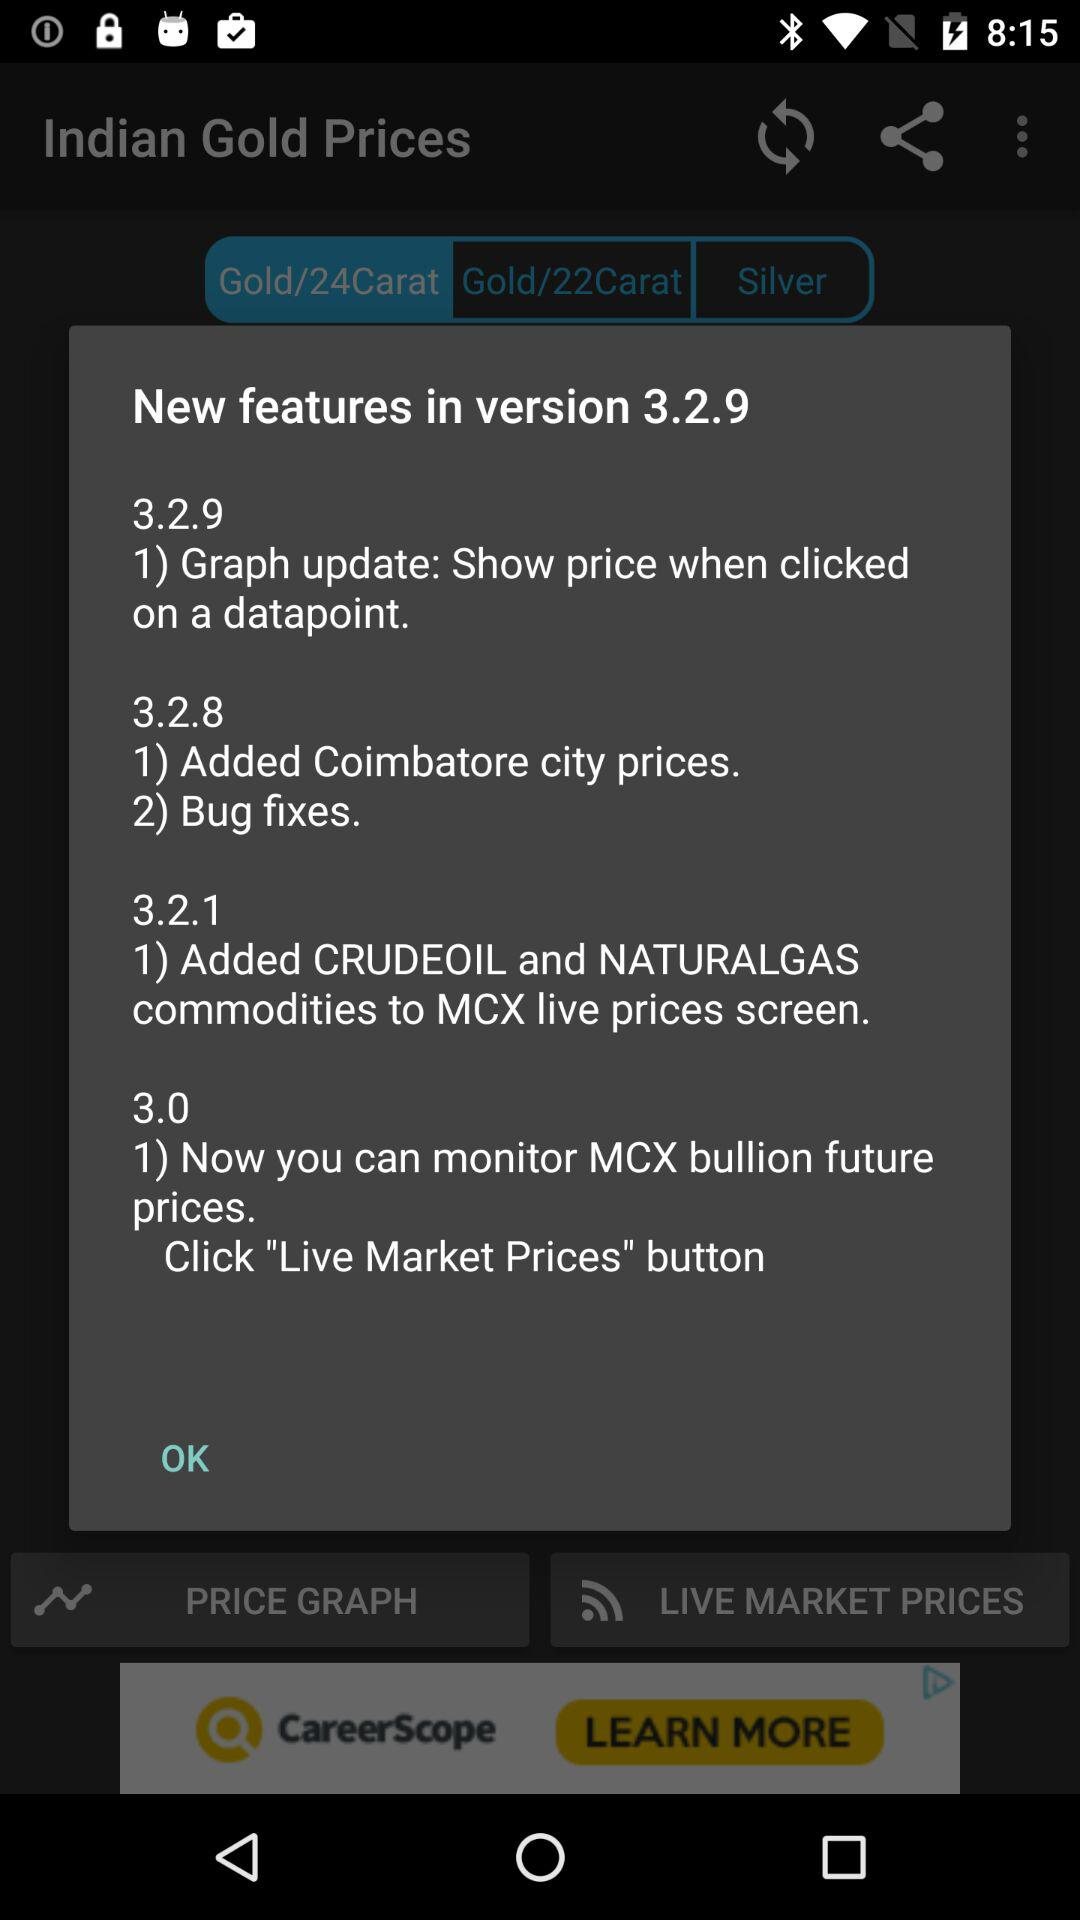What are the new features in version 3.0? The new feature in version 3.0 is "Now you can monitor MCX bullion future prices". 